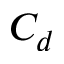<formula> <loc_0><loc_0><loc_500><loc_500>C _ { d }</formula> 